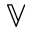<formula> <loc_0><loc_0><loc_500><loc_500>\mathbb { V }</formula> 